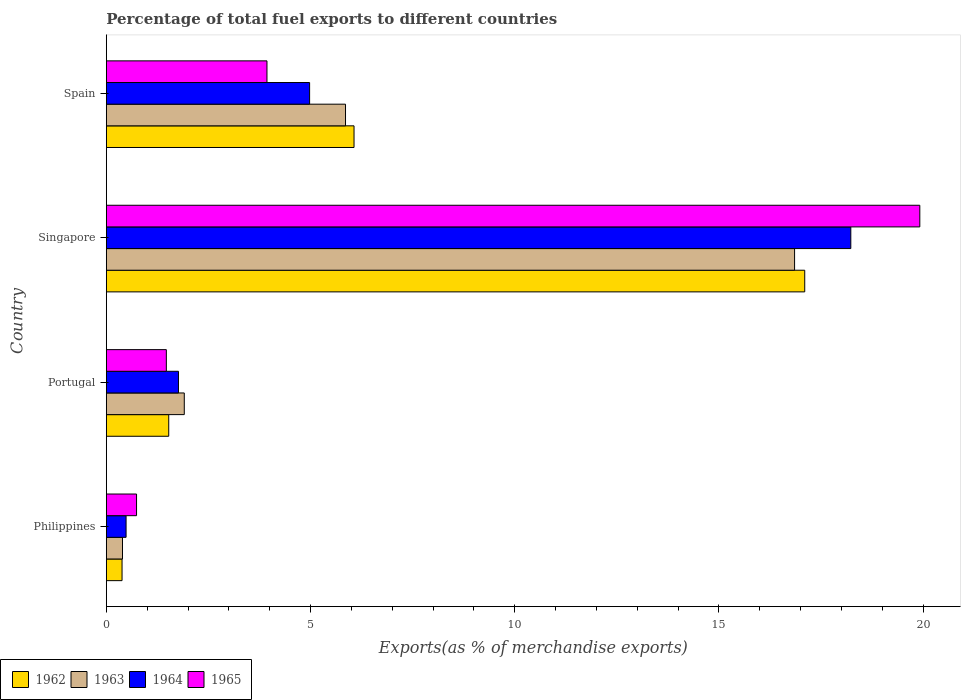How many different coloured bars are there?
Provide a succinct answer. 4. In how many cases, is the number of bars for a given country not equal to the number of legend labels?
Keep it short and to the point. 0. What is the percentage of exports to different countries in 1962 in Spain?
Provide a short and direct response. 6.07. Across all countries, what is the maximum percentage of exports to different countries in 1963?
Your answer should be very brief. 16.85. Across all countries, what is the minimum percentage of exports to different countries in 1962?
Make the answer very short. 0.38. In which country was the percentage of exports to different countries in 1964 maximum?
Offer a very short reply. Singapore. In which country was the percentage of exports to different countries in 1965 minimum?
Keep it short and to the point. Philippines. What is the total percentage of exports to different countries in 1962 in the graph?
Your answer should be compact. 25.08. What is the difference between the percentage of exports to different countries in 1963 in Singapore and that in Spain?
Keep it short and to the point. 11. What is the difference between the percentage of exports to different countries in 1963 in Philippines and the percentage of exports to different countries in 1965 in Spain?
Provide a succinct answer. -3.54. What is the average percentage of exports to different countries in 1962 per country?
Provide a short and direct response. 6.27. What is the difference between the percentage of exports to different countries in 1962 and percentage of exports to different countries in 1964 in Spain?
Your answer should be compact. 1.09. In how many countries, is the percentage of exports to different countries in 1962 greater than 10 %?
Offer a terse response. 1. What is the ratio of the percentage of exports to different countries in 1963 in Portugal to that in Singapore?
Provide a succinct answer. 0.11. Is the difference between the percentage of exports to different countries in 1962 in Philippines and Spain greater than the difference between the percentage of exports to different countries in 1964 in Philippines and Spain?
Give a very brief answer. No. What is the difference between the highest and the second highest percentage of exports to different countries in 1962?
Provide a succinct answer. 11.04. What is the difference between the highest and the lowest percentage of exports to different countries in 1962?
Ensure brevity in your answer.  16.72. Is the sum of the percentage of exports to different countries in 1965 in Singapore and Spain greater than the maximum percentage of exports to different countries in 1964 across all countries?
Give a very brief answer. Yes. What does the 1st bar from the top in Singapore represents?
Offer a very short reply. 1965. What does the 3rd bar from the bottom in Spain represents?
Your answer should be compact. 1964. Are all the bars in the graph horizontal?
Your answer should be compact. Yes. How many countries are there in the graph?
Your answer should be very brief. 4. What is the difference between two consecutive major ticks on the X-axis?
Your answer should be compact. 5. Are the values on the major ticks of X-axis written in scientific E-notation?
Offer a very short reply. No. Does the graph contain any zero values?
Offer a terse response. No. Where does the legend appear in the graph?
Your answer should be compact. Bottom left. How are the legend labels stacked?
Your answer should be very brief. Horizontal. What is the title of the graph?
Offer a terse response. Percentage of total fuel exports to different countries. What is the label or title of the X-axis?
Offer a very short reply. Exports(as % of merchandise exports). What is the label or title of the Y-axis?
Ensure brevity in your answer.  Country. What is the Exports(as % of merchandise exports) in 1962 in Philippines?
Ensure brevity in your answer.  0.38. What is the Exports(as % of merchandise exports) of 1963 in Philippines?
Your answer should be compact. 0.4. What is the Exports(as % of merchandise exports) of 1964 in Philippines?
Keep it short and to the point. 0.48. What is the Exports(as % of merchandise exports) in 1965 in Philippines?
Your answer should be very brief. 0.74. What is the Exports(as % of merchandise exports) in 1962 in Portugal?
Offer a very short reply. 1.53. What is the Exports(as % of merchandise exports) of 1963 in Portugal?
Your answer should be very brief. 1.91. What is the Exports(as % of merchandise exports) of 1964 in Portugal?
Make the answer very short. 1.77. What is the Exports(as % of merchandise exports) of 1965 in Portugal?
Provide a succinct answer. 1.47. What is the Exports(as % of merchandise exports) of 1962 in Singapore?
Your answer should be very brief. 17.1. What is the Exports(as % of merchandise exports) of 1963 in Singapore?
Offer a terse response. 16.85. What is the Exports(as % of merchandise exports) of 1964 in Singapore?
Make the answer very short. 18.23. What is the Exports(as % of merchandise exports) of 1965 in Singapore?
Provide a short and direct response. 19.92. What is the Exports(as % of merchandise exports) of 1962 in Spain?
Provide a succinct answer. 6.07. What is the Exports(as % of merchandise exports) of 1963 in Spain?
Offer a very short reply. 5.86. What is the Exports(as % of merchandise exports) of 1964 in Spain?
Your answer should be compact. 4.98. What is the Exports(as % of merchandise exports) in 1965 in Spain?
Keep it short and to the point. 3.93. Across all countries, what is the maximum Exports(as % of merchandise exports) of 1962?
Ensure brevity in your answer.  17.1. Across all countries, what is the maximum Exports(as % of merchandise exports) in 1963?
Give a very brief answer. 16.85. Across all countries, what is the maximum Exports(as % of merchandise exports) of 1964?
Keep it short and to the point. 18.23. Across all countries, what is the maximum Exports(as % of merchandise exports) of 1965?
Give a very brief answer. 19.92. Across all countries, what is the minimum Exports(as % of merchandise exports) of 1962?
Ensure brevity in your answer.  0.38. Across all countries, what is the minimum Exports(as % of merchandise exports) of 1963?
Your response must be concise. 0.4. Across all countries, what is the minimum Exports(as % of merchandise exports) in 1964?
Offer a very short reply. 0.48. Across all countries, what is the minimum Exports(as % of merchandise exports) in 1965?
Your response must be concise. 0.74. What is the total Exports(as % of merchandise exports) of 1962 in the graph?
Offer a very short reply. 25.08. What is the total Exports(as % of merchandise exports) of 1963 in the graph?
Ensure brevity in your answer.  25.02. What is the total Exports(as % of merchandise exports) in 1964 in the graph?
Offer a very short reply. 25.46. What is the total Exports(as % of merchandise exports) in 1965 in the graph?
Give a very brief answer. 26.07. What is the difference between the Exports(as % of merchandise exports) in 1962 in Philippines and that in Portugal?
Your answer should be very brief. -1.14. What is the difference between the Exports(as % of merchandise exports) in 1963 in Philippines and that in Portugal?
Keep it short and to the point. -1.51. What is the difference between the Exports(as % of merchandise exports) of 1964 in Philippines and that in Portugal?
Offer a terse response. -1.28. What is the difference between the Exports(as % of merchandise exports) in 1965 in Philippines and that in Portugal?
Provide a succinct answer. -0.73. What is the difference between the Exports(as % of merchandise exports) of 1962 in Philippines and that in Singapore?
Provide a short and direct response. -16.72. What is the difference between the Exports(as % of merchandise exports) in 1963 in Philippines and that in Singapore?
Ensure brevity in your answer.  -16.46. What is the difference between the Exports(as % of merchandise exports) of 1964 in Philippines and that in Singapore?
Give a very brief answer. -17.75. What is the difference between the Exports(as % of merchandise exports) of 1965 in Philippines and that in Singapore?
Your response must be concise. -19.18. What is the difference between the Exports(as % of merchandise exports) in 1962 in Philippines and that in Spain?
Your answer should be compact. -5.68. What is the difference between the Exports(as % of merchandise exports) of 1963 in Philippines and that in Spain?
Your answer should be compact. -5.46. What is the difference between the Exports(as % of merchandise exports) of 1964 in Philippines and that in Spain?
Offer a terse response. -4.49. What is the difference between the Exports(as % of merchandise exports) of 1965 in Philippines and that in Spain?
Make the answer very short. -3.19. What is the difference between the Exports(as % of merchandise exports) of 1962 in Portugal and that in Singapore?
Ensure brevity in your answer.  -15.58. What is the difference between the Exports(as % of merchandise exports) in 1963 in Portugal and that in Singapore?
Your answer should be compact. -14.95. What is the difference between the Exports(as % of merchandise exports) in 1964 in Portugal and that in Singapore?
Your response must be concise. -16.47. What is the difference between the Exports(as % of merchandise exports) of 1965 in Portugal and that in Singapore?
Ensure brevity in your answer.  -18.45. What is the difference between the Exports(as % of merchandise exports) of 1962 in Portugal and that in Spain?
Provide a succinct answer. -4.54. What is the difference between the Exports(as % of merchandise exports) of 1963 in Portugal and that in Spain?
Offer a very short reply. -3.95. What is the difference between the Exports(as % of merchandise exports) in 1964 in Portugal and that in Spain?
Provide a succinct answer. -3.21. What is the difference between the Exports(as % of merchandise exports) of 1965 in Portugal and that in Spain?
Your response must be concise. -2.46. What is the difference between the Exports(as % of merchandise exports) in 1962 in Singapore and that in Spain?
Your response must be concise. 11.04. What is the difference between the Exports(as % of merchandise exports) in 1963 in Singapore and that in Spain?
Make the answer very short. 11. What is the difference between the Exports(as % of merchandise exports) of 1964 in Singapore and that in Spain?
Your answer should be compact. 13.25. What is the difference between the Exports(as % of merchandise exports) of 1965 in Singapore and that in Spain?
Ensure brevity in your answer.  15.99. What is the difference between the Exports(as % of merchandise exports) in 1962 in Philippines and the Exports(as % of merchandise exports) in 1963 in Portugal?
Your answer should be compact. -1.52. What is the difference between the Exports(as % of merchandise exports) of 1962 in Philippines and the Exports(as % of merchandise exports) of 1964 in Portugal?
Give a very brief answer. -1.38. What is the difference between the Exports(as % of merchandise exports) in 1962 in Philippines and the Exports(as % of merchandise exports) in 1965 in Portugal?
Keep it short and to the point. -1.08. What is the difference between the Exports(as % of merchandise exports) in 1963 in Philippines and the Exports(as % of merchandise exports) in 1964 in Portugal?
Make the answer very short. -1.37. What is the difference between the Exports(as % of merchandise exports) in 1963 in Philippines and the Exports(as % of merchandise exports) in 1965 in Portugal?
Make the answer very short. -1.07. What is the difference between the Exports(as % of merchandise exports) of 1964 in Philippines and the Exports(as % of merchandise exports) of 1965 in Portugal?
Keep it short and to the point. -0.99. What is the difference between the Exports(as % of merchandise exports) in 1962 in Philippines and the Exports(as % of merchandise exports) in 1963 in Singapore?
Your answer should be compact. -16.47. What is the difference between the Exports(as % of merchandise exports) of 1962 in Philippines and the Exports(as % of merchandise exports) of 1964 in Singapore?
Provide a short and direct response. -17.85. What is the difference between the Exports(as % of merchandise exports) of 1962 in Philippines and the Exports(as % of merchandise exports) of 1965 in Singapore?
Give a very brief answer. -19.54. What is the difference between the Exports(as % of merchandise exports) of 1963 in Philippines and the Exports(as % of merchandise exports) of 1964 in Singapore?
Ensure brevity in your answer.  -17.84. What is the difference between the Exports(as % of merchandise exports) of 1963 in Philippines and the Exports(as % of merchandise exports) of 1965 in Singapore?
Give a very brief answer. -19.53. What is the difference between the Exports(as % of merchandise exports) of 1964 in Philippines and the Exports(as % of merchandise exports) of 1965 in Singapore?
Your answer should be very brief. -19.44. What is the difference between the Exports(as % of merchandise exports) in 1962 in Philippines and the Exports(as % of merchandise exports) in 1963 in Spain?
Provide a succinct answer. -5.47. What is the difference between the Exports(as % of merchandise exports) of 1962 in Philippines and the Exports(as % of merchandise exports) of 1964 in Spain?
Offer a very short reply. -4.59. What is the difference between the Exports(as % of merchandise exports) in 1962 in Philippines and the Exports(as % of merchandise exports) in 1965 in Spain?
Your response must be concise. -3.55. What is the difference between the Exports(as % of merchandise exports) in 1963 in Philippines and the Exports(as % of merchandise exports) in 1964 in Spain?
Give a very brief answer. -4.58. What is the difference between the Exports(as % of merchandise exports) of 1963 in Philippines and the Exports(as % of merchandise exports) of 1965 in Spain?
Your answer should be compact. -3.54. What is the difference between the Exports(as % of merchandise exports) of 1964 in Philippines and the Exports(as % of merchandise exports) of 1965 in Spain?
Make the answer very short. -3.45. What is the difference between the Exports(as % of merchandise exports) of 1962 in Portugal and the Exports(as % of merchandise exports) of 1963 in Singapore?
Make the answer very short. -15.33. What is the difference between the Exports(as % of merchandise exports) in 1962 in Portugal and the Exports(as % of merchandise exports) in 1964 in Singapore?
Keep it short and to the point. -16.7. What is the difference between the Exports(as % of merchandise exports) in 1962 in Portugal and the Exports(as % of merchandise exports) in 1965 in Singapore?
Your answer should be compact. -18.39. What is the difference between the Exports(as % of merchandise exports) in 1963 in Portugal and the Exports(as % of merchandise exports) in 1964 in Singapore?
Offer a very short reply. -16.32. What is the difference between the Exports(as % of merchandise exports) of 1963 in Portugal and the Exports(as % of merchandise exports) of 1965 in Singapore?
Offer a terse response. -18.01. What is the difference between the Exports(as % of merchandise exports) of 1964 in Portugal and the Exports(as % of merchandise exports) of 1965 in Singapore?
Ensure brevity in your answer.  -18.16. What is the difference between the Exports(as % of merchandise exports) of 1962 in Portugal and the Exports(as % of merchandise exports) of 1963 in Spain?
Keep it short and to the point. -4.33. What is the difference between the Exports(as % of merchandise exports) of 1962 in Portugal and the Exports(as % of merchandise exports) of 1964 in Spain?
Make the answer very short. -3.45. What is the difference between the Exports(as % of merchandise exports) in 1962 in Portugal and the Exports(as % of merchandise exports) in 1965 in Spain?
Your response must be concise. -2.41. What is the difference between the Exports(as % of merchandise exports) of 1963 in Portugal and the Exports(as % of merchandise exports) of 1964 in Spain?
Your response must be concise. -3.07. What is the difference between the Exports(as % of merchandise exports) of 1963 in Portugal and the Exports(as % of merchandise exports) of 1965 in Spain?
Keep it short and to the point. -2.03. What is the difference between the Exports(as % of merchandise exports) of 1964 in Portugal and the Exports(as % of merchandise exports) of 1965 in Spain?
Offer a very short reply. -2.17. What is the difference between the Exports(as % of merchandise exports) of 1962 in Singapore and the Exports(as % of merchandise exports) of 1963 in Spain?
Your answer should be very brief. 11.25. What is the difference between the Exports(as % of merchandise exports) in 1962 in Singapore and the Exports(as % of merchandise exports) in 1964 in Spain?
Keep it short and to the point. 12.13. What is the difference between the Exports(as % of merchandise exports) in 1962 in Singapore and the Exports(as % of merchandise exports) in 1965 in Spain?
Offer a very short reply. 13.17. What is the difference between the Exports(as % of merchandise exports) in 1963 in Singapore and the Exports(as % of merchandise exports) in 1964 in Spain?
Provide a succinct answer. 11.88. What is the difference between the Exports(as % of merchandise exports) in 1963 in Singapore and the Exports(as % of merchandise exports) in 1965 in Spain?
Provide a short and direct response. 12.92. What is the difference between the Exports(as % of merchandise exports) in 1964 in Singapore and the Exports(as % of merchandise exports) in 1965 in Spain?
Keep it short and to the point. 14.3. What is the average Exports(as % of merchandise exports) of 1962 per country?
Make the answer very short. 6.27. What is the average Exports(as % of merchandise exports) in 1963 per country?
Your response must be concise. 6.25. What is the average Exports(as % of merchandise exports) in 1964 per country?
Provide a succinct answer. 6.37. What is the average Exports(as % of merchandise exports) of 1965 per country?
Give a very brief answer. 6.52. What is the difference between the Exports(as % of merchandise exports) in 1962 and Exports(as % of merchandise exports) in 1963 in Philippines?
Make the answer very short. -0.01. What is the difference between the Exports(as % of merchandise exports) in 1962 and Exports(as % of merchandise exports) in 1964 in Philippines?
Give a very brief answer. -0.1. What is the difference between the Exports(as % of merchandise exports) of 1962 and Exports(as % of merchandise exports) of 1965 in Philippines?
Ensure brevity in your answer.  -0.35. What is the difference between the Exports(as % of merchandise exports) of 1963 and Exports(as % of merchandise exports) of 1964 in Philippines?
Your response must be concise. -0.09. What is the difference between the Exports(as % of merchandise exports) in 1963 and Exports(as % of merchandise exports) in 1965 in Philippines?
Your answer should be very brief. -0.34. What is the difference between the Exports(as % of merchandise exports) of 1964 and Exports(as % of merchandise exports) of 1965 in Philippines?
Your answer should be compact. -0.26. What is the difference between the Exports(as % of merchandise exports) in 1962 and Exports(as % of merchandise exports) in 1963 in Portugal?
Make the answer very short. -0.38. What is the difference between the Exports(as % of merchandise exports) in 1962 and Exports(as % of merchandise exports) in 1964 in Portugal?
Offer a very short reply. -0.24. What is the difference between the Exports(as % of merchandise exports) of 1962 and Exports(as % of merchandise exports) of 1965 in Portugal?
Your answer should be very brief. 0.06. What is the difference between the Exports(as % of merchandise exports) of 1963 and Exports(as % of merchandise exports) of 1964 in Portugal?
Ensure brevity in your answer.  0.14. What is the difference between the Exports(as % of merchandise exports) in 1963 and Exports(as % of merchandise exports) in 1965 in Portugal?
Provide a short and direct response. 0.44. What is the difference between the Exports(as % of merchandise exports) of 1964 and Exports(as % of merchandise exports) of 1965 in Portugal?
Provide a succinct answer. 0.3. What is the difference between the Exports(as % of merchandise exports) in 1962 and Exports(as % of merchandise exports) in 1963 in Singapore?
Your answer should be very brief. 0.25. What is the difference between the Exports(as % of merchandise exports) in 1962 and Exports(as % of merchandise exports) in 1964 in Singapore?
Your answer should be very brief. -1.13. What is the difference between the Exports(as % of merchandise exports) in 1962 and Exports(as % of merchandise exports) in 1965 in Singapore?
Your answer should be very brief. -2.82. What is the difference between the Exports(as % of merchandise exports) of 1963 and Exports(as % of merchandise exports) of 1964 in Singapore?
Your answer should be very brief. -1.38. What is the difference between the Exports(as % of merchandise exports) of 1963 and Exports(as % of merchandise exports) of 1965 in Singapore?
Provide a succinct answer. -3.07. What is the difference between the Exports(as % of merchandise exports) of 1964 and Exports(as % of merchandise exports) of 1965 in Singapore?
Give a very brief answer. -1.69. What is the difference between the Exports(as % of merchandise exports) in 1962 and Exports(as % of merchandise exports) in 1963 in Spain?
Make the answer very short. 0.21. What is the difference between the Exports(as % of merchandise exports) in 1962 and Exports(as % of merchandise exports) in 1964 in Spain?
Make the answer very short. 1.09. What is the difference between the Exports(as % of merchandise exports) in 1962 and Exports(as % of merchandise exports) in 1965 in Spain?
Your answer should be very brief. 2.13. What is the difference between the Exports(as % of merchandise exports) of 1963 and Exports(as % of merchandise exports) of 1964 in Spain?
Ensure brevity in your answer.  0.88. What is the difference between the Exports(as % of merchandise exports) of 1963 and Exports(as % of merchandise exports) of 1965 in Spain?
Ensure brevity in your answer.  1.92. What is the difference between the Exports(as % of merchandise exports) of 1964 and Exports(as % of merchandise exports) of 1965 in Spain?
Provide a succinct answer. 1.04. What is the ratio of the Exports(as % of merchandise exports) of 1962 in Philippines to that in Portugal?
Offer a very short reply. 0.25. What is the ratio of the Exports(as % of merchandise exports) of 1963 in Philippines to that in Portugal?
Offer a very short reply. 0.21. What is the ratio of the Exports(as % of merchandise exports) in 1964 in Philippines to that in Portugal?
Make the answer very short. 0.27. What is the ratio of the Exports(as % of merchandise exports) in 1965 in Philippines to that in Portugal?
Your answer should be very brief. 0.5. What is the ratio of the Exports(as % of merchandise exports) of 1962 in Philippines to that in Singapore?
Your response must be concise. 0.02. What is the ratio of the Exports(as % of merchandise exports) in 1963 in Philippines to that in Singapore?
Offer a terse response. 0.02. What is the ratio of the Exports(as % of merchandise exports) of 1964 in Philippines to that in Singapore?
Ensure brevity in your answer.  0.03. What is the ratio of the Exports(as % of merchandise exports) of 1965 in Philippines to that in Singapore?
Make the answer very short. 0.04. What is the ratio of the Exports(as % of merchandise exports) of 1962 in Philippines to that in Spain?
Your response must be concise. 0.06. What is the ratio of the Exports(as % of merchandise exports) in 1963 in Philippines to that in Spain?
Provide a short and direct response. 0.07. What is the ratio of the Exports(as % of merchandise exports) of 1964 in Philippines to that in Spain?
Offer a terse response. 0.1. What is the ratio of the Exports(as % of merchandise exports) of 1965 in Philippines to that in Spain?
Your answer should be very brief. 0.19. What is the ratio of the Exports(as % of merchandise exports) in 1962 in Portugal to that in Singapore?
Your answer should be very brief. 0.09. What is the ratio of the Exports(as % of merchandise exports) of 1963 in Portugal to that in Singapore?
Offer a very short reply. 0.11. What is the ratio of the Exports(as % of merchandise exports) of 1964 in Portugal to that in Singapore?
Provide a succinct answer. 0.1. What is the ratio of the Exports(as % of merchandise exports) in 1965 in Portugal to that in Singapore?
Your answer should be very brief. 0.07. What is the ratio of the Exports(as % of merchandise exports) of 1962 in Portugal to that in Spain?
Your response must be concise. 0.25. What is the ratio of the Exports(as % of merchandise exports) of 1963 in Portugal to that in Spain?
Your answer should be compact. 0.33. What is the ratio of the Exports(as % of merchandise exports) in 1964 in Portugal to that in Spain?
Ensure brevity in your answer.  0.35. What is the ratio of the Exports(as % of merchandise exports) of 1965 in Portugal to that in Spain?
Keep it short and to the point. 0.37. What is the ratio of the Exports(as % of merchandise exports) in 1962 in Singapore to that in Spain?
Ensure brevity in your answer.  2.82. What is the ratio of the Exports(as % of merchandise exports) in 1963 in Singapore to that in Spain?
Make the answer very short. 2.88. What is the ratio of the Exports(as % of merchandise exports) in 1964 in Singapore to that in Spain?
Your answer should be very brief. 3.66. What is the ratio of the Exports(as % of merchandise exports) of 1965 in Singapore to that in Spain?
Make the answer very short. 5.06. What is the difference between the highest and the second highest Exports(as % of merchandise exports) of 1962?
Offer a very short reply. 11.04. What is the difference between the highest and the second highest Exports(as % of merchandise exports) in 1963?
Your response must be concise. 11. What is the difference between the highest and the second highest Exports(as % of merchandise exports) of 1964?
Your answer should be compact. 13.25. What is the difference between the highest and the second highest Exports(as % of merchandise exports) in 1965?
Your response must be concise. 15.99. What is the difference between the highest and the lowest Exports(as % of merchandise exports) of 1962?
Give a very brief answer. 16.72. What is the difference between the highest and the lowest Exports(as % of merchandise exports) in 1963?
Ensure brevity in your answer.  16.46. What is the difference between the highest and the lowest Exports(as % of merchandise exports) in 1964?
Your answer should be very brief. 17.75. What is the difference between the highest and the lowest Exports(as % of merchandise exports) of 1965?
Offer a terse response. 19.18. 